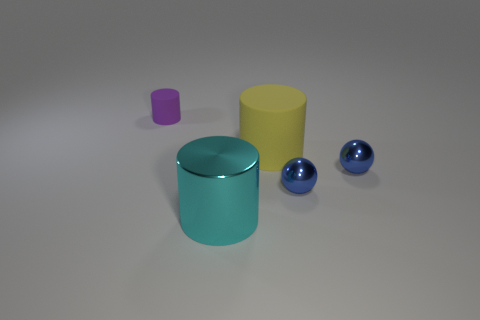How would you describe the arrangement of the objects in this scene? The objects in the image are arranged with an emphasis on balance and symmetry. Two blue spheres are placed roughly parallel to each other, flanking a trio of cylinders - a large teal one, a medium yellow, and a small purple one. The positioning allows for a clear view of each object's color and size, suggesting a deliberate attempt to showcase their differences and similarities. 